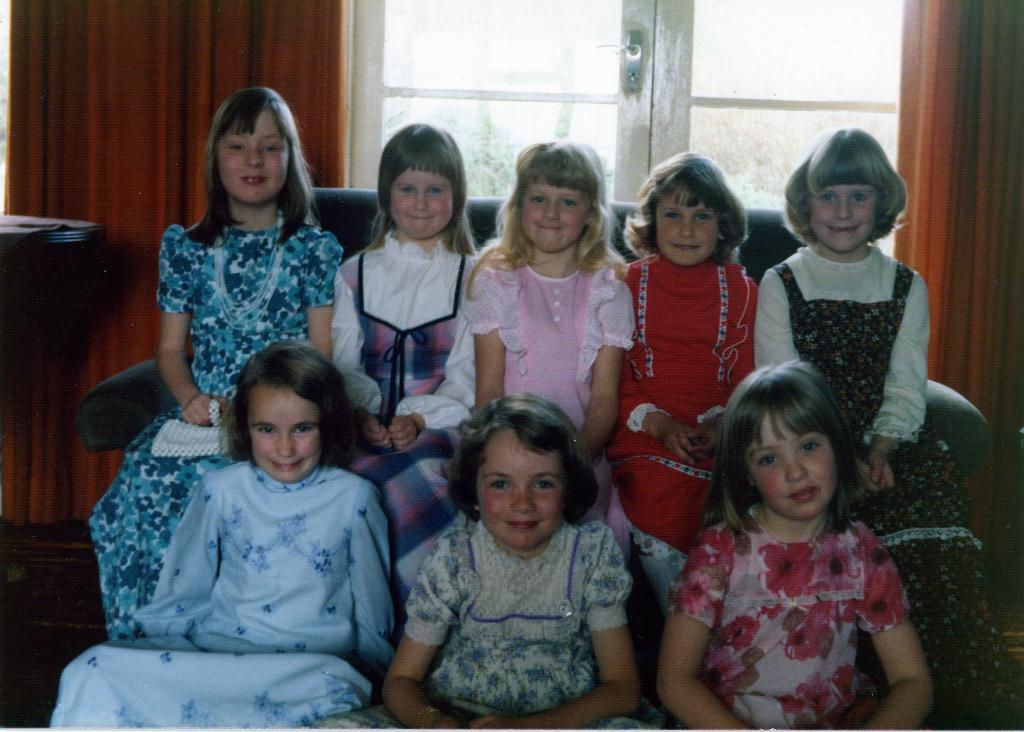How many girls are present in the image? There are eight girls in the image. Where are the majority of the girls sitting? Five of the girls are sitting on a couch. How many girls are sitting on the floor? Three of the girls are sitting on the floor. What can be seen on the left side of the image? There is a table on the left side of the image. What type of needle is being used by the girls to attack each other in the image? There is no indication in the image that the girls are attacking each other or using any type of needle. 